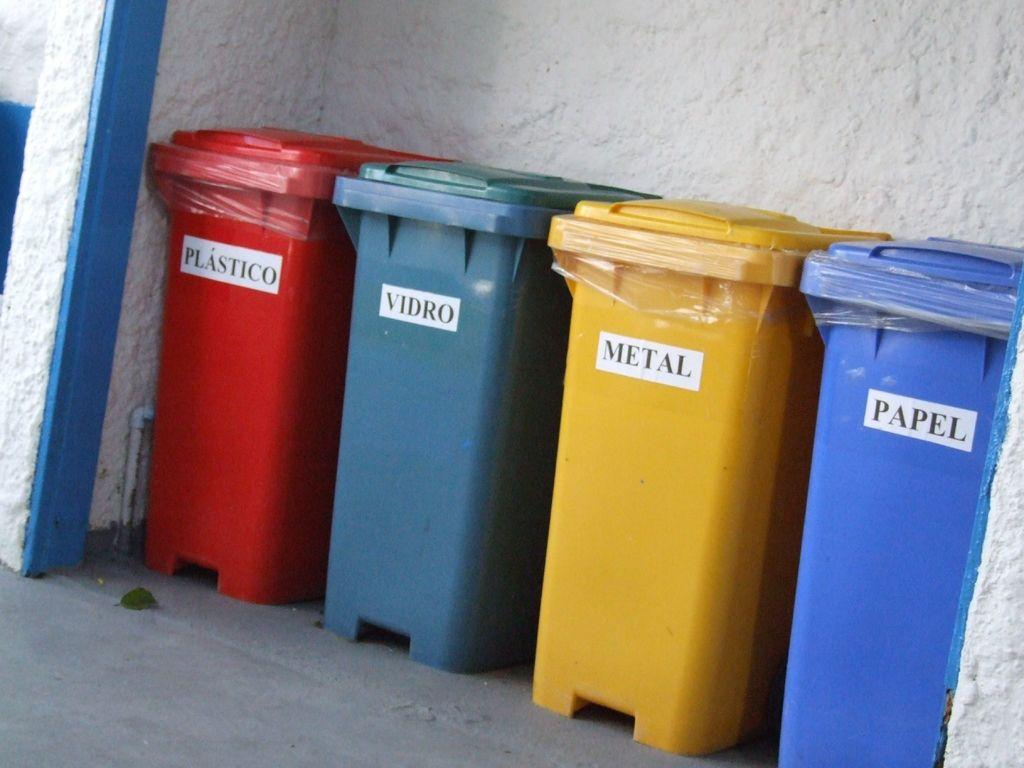Provide a one-sentence caption for the provided image. Various colored bins, some are for different recycling pieces and the wording may be in spanish. 